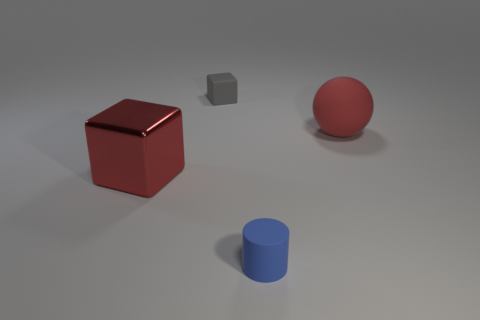What shape is the tiny gray object that is the same material as the small cylinder?
Provide a succinct answer. Cube. What number of big objects are red shiny cubes or red things?
Ensure brevity in your answer.  2. What number of other things are the same color as the large rubber thing?
Offer a terse response. 1. How many tiny cylinders are in front of the small matte object behind the cylinder that is in front of the tiny gray cube?
Your answer should be very brief. 1. Do the cube that is to the right of the red shiny cube and the small blue matte object have the same size?
Keep it short and to the point. Yes. Are there fewer red spheres right of the matte ball than matte cylinders that are behind the red shiny object?
Your answer should be very brief. No. Is the big matte ball the same color as the large shiny thing?
Your answer should be very brief. Yes. Is the number of blue things that are to the left of the red shiny cube less than the number of gray shiny blocks?
Provide a short and direct response. No. What is the material of the big ball that is the same color as the big shiny block?
Offer a terse response. Rubber. Is the large ball made of the same material as the big red cube?
Keep it short and to the point. No. 